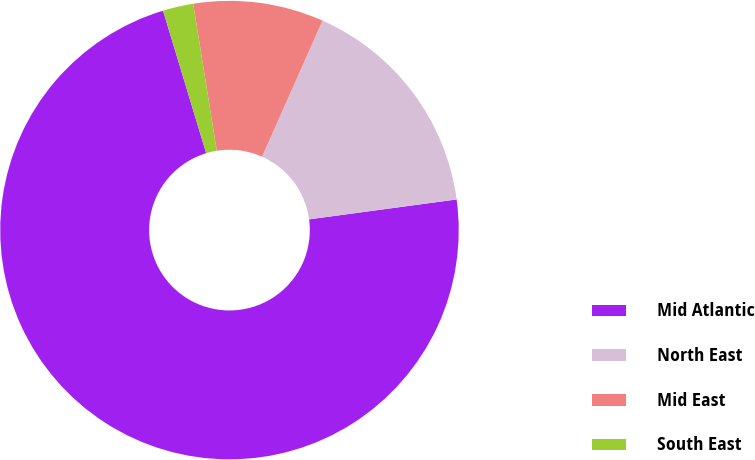Convert chart. <chart><loc_0><loc_0><loc_500><loc_500><pie_chart><fcel>Mid Atlantic<fcel>North East<fcel>Mid East<fcel>South East<nl><fcel>72.45%<fcel>16.21%<fcel>9.18%<fcel>2.15%<nl></chart> 